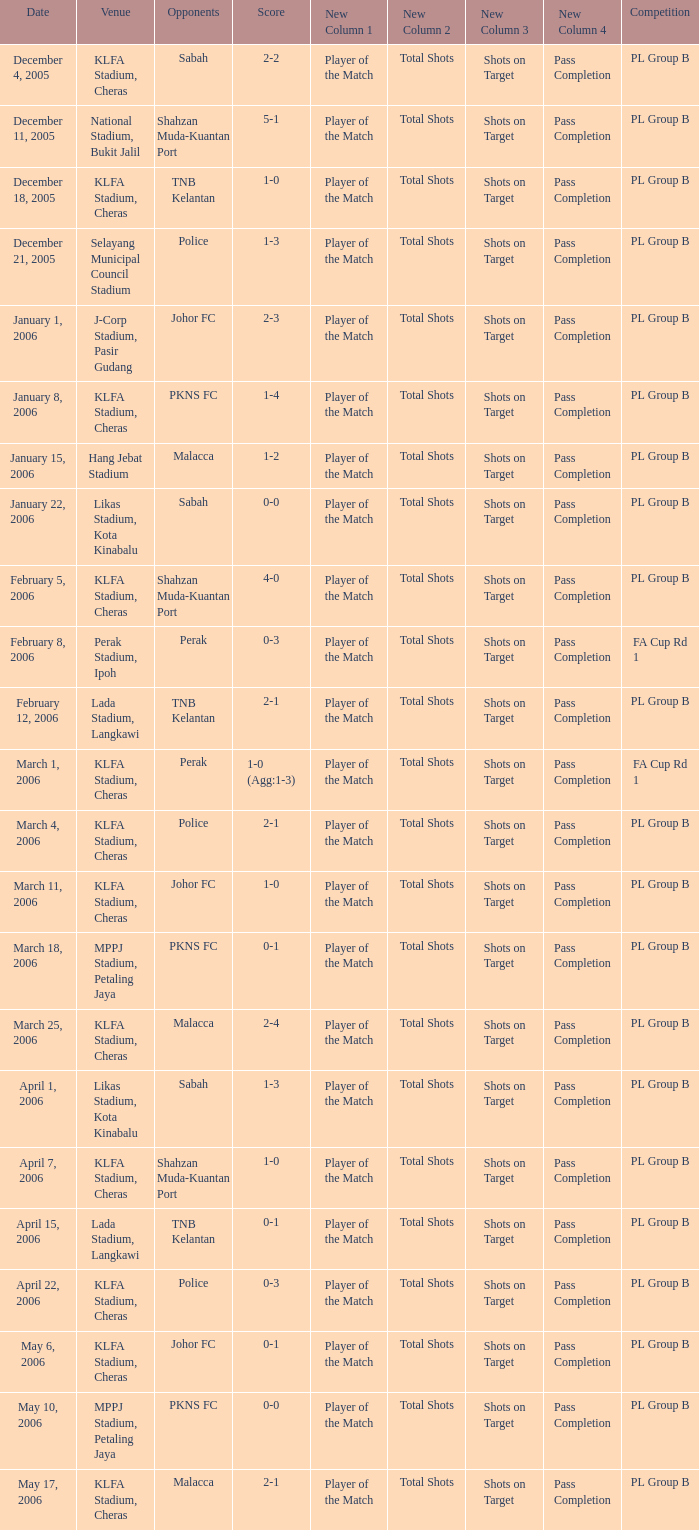Which Venue has a Competition of pl group b, and a Score of 2-2? KLFA Stadium, Cheras. 